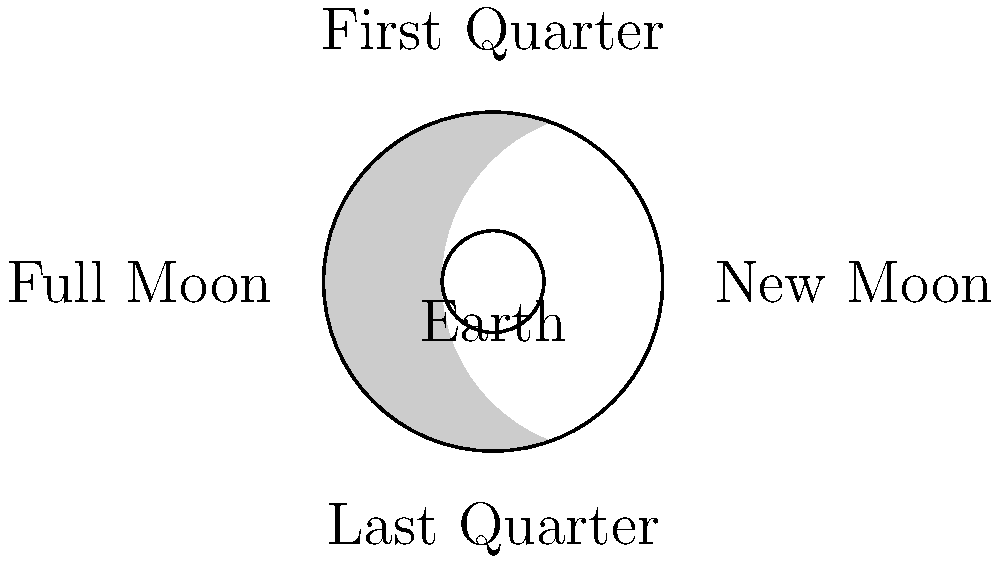In the diagram above, which phase of the Moon would Burna Boy see if he were looking at the Moon from Earth when it's positioned at the top of the circle? Let's break this down step-by-step:

1. The diagram shows the Moon's orbit around Earth from a top-down view.
2. Earth is at the center of the diagram.
3. The Moon's phases are determined by how much of its illuminated surface is visible from Earth.
4. When the Moon is at the top of the circle in the diagram:
   - It's positioned between the Sun and Earth.
   - Half of the Moon is illuminated by the Sun (the right half in this diagram).
   - From Earth's perspective, we see the right edge of the Moon illuminated.
5. This position corresponds to the First Quarter phase.
6. In the First Quarter phase, exactly half of the Moon's visible surface is illuminated from Earth's perspective, appearing as a "half-moon" shape.

Relating to Burna Boy: Just as Burna Boy's music often reflects a journey or progression, the Moon's phases represent a cyclical journey around Earth, with the First Quarter marking a significant point in this cycle.
Answer: First Quarter 